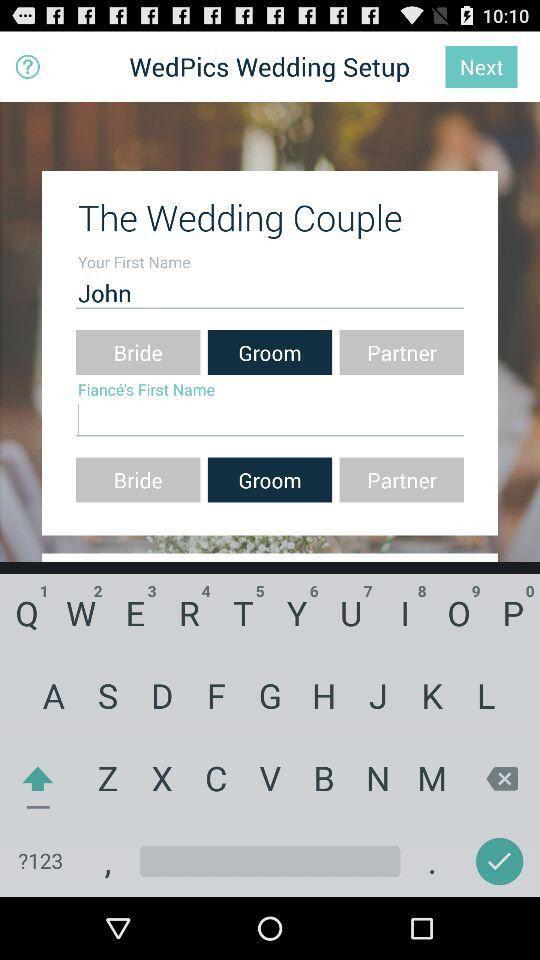Who will receive the public profile, relationships and email address? The public profile, relationships and email address received by "WedPics". 